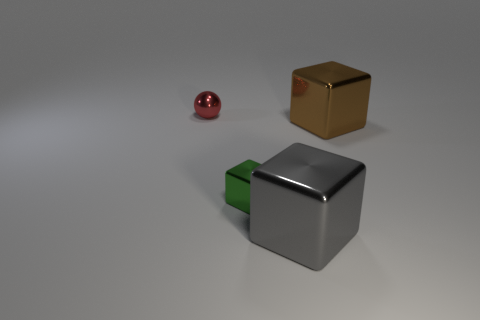Subtract all gray blocks. Subtract all gray cylinders. How many blocks are left? 2 Add 2 small objects. How many objects exist? 6 Subtract all spheres. How many objects are left? 3 Add 1 small yellow metallic blocks. How many small yellow metallic blocks exist? 1 Subtract 0 purple blocks. How many objects are left? 4 Subtract all cyan matte blocks. Subtract all tiny cubes. How many objects are left? 3 Add 4 green shiny blocks. How many green shiny blocks are left? 5 